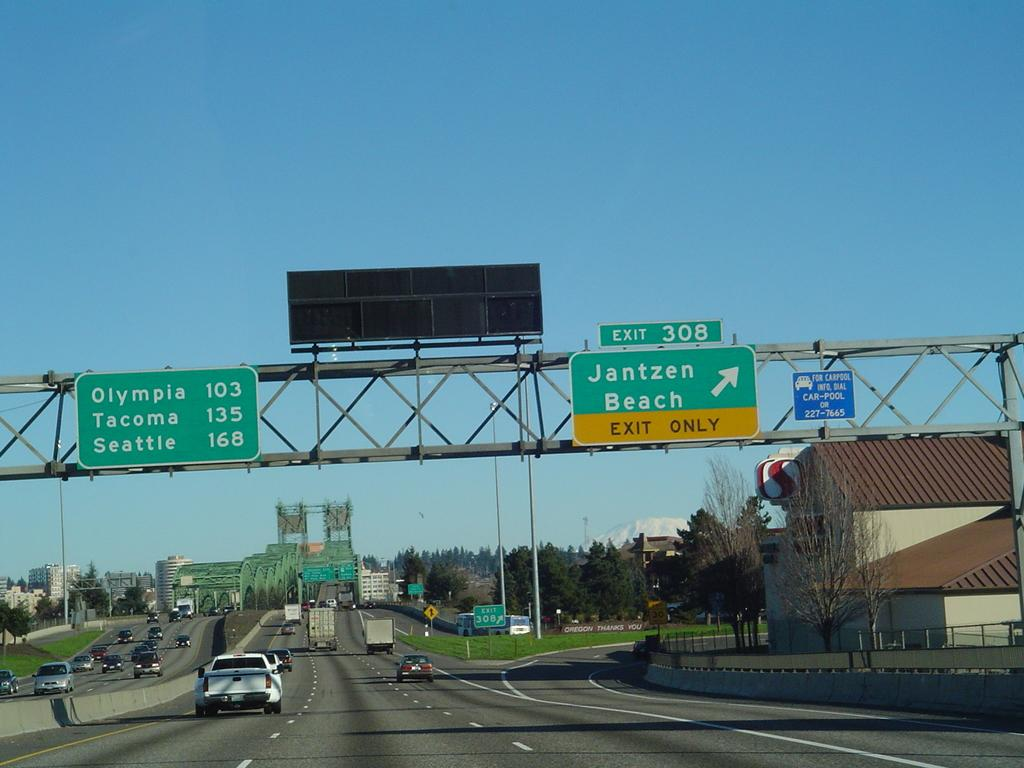<image>
Share a concise interpretation of the image provided. Sunny day on the a four lane highway with choices for a trip into the city or the beach. 